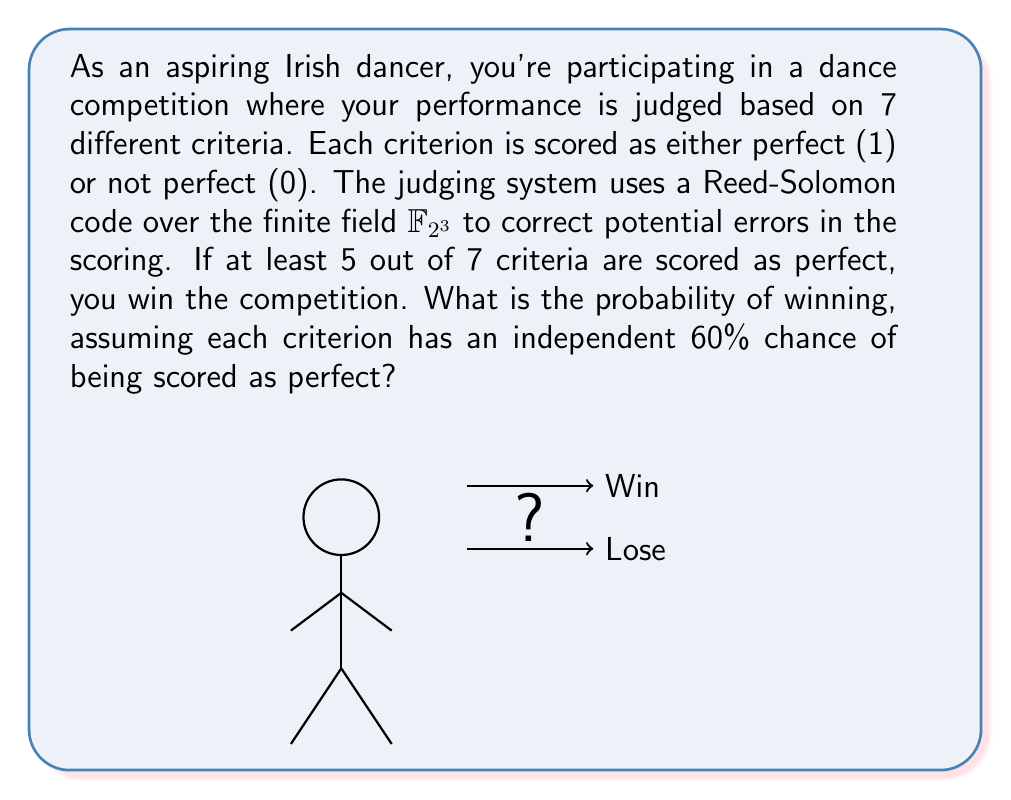Can you answer this question? Let's approach this step-by-step:

1) First, we need to understand that we're dealing with a binomial probability distribution. We have 7 independent trials (criteria), each with a 60% chance of success.

2) We win if we get 5, 6, or 7 perfect scores. So we need to calculate:
   $P(\text{win}) = P(X=5) + P(X=6) + P(X=7)$
   where $X$ is the number of perfect scores.

3) The probability of each outcome is given by the binomial probability formula:
   $P(X=k) = \binom{n}{k} p^k (1-p)^{n-k}$
   where $n=7$, $p=0.6$, and $k$ is the number of successes.

4) Let's calculate each probability:

   For $k=5$: 
   $P(X=5) = \binom{7}{5} (0.6)^5 (0.4)^2 = 21 \cdot 0.07776 \cdot 0.16 = 0.2592$

   For $k=6$:
   $P(X=6) = \binom{7}{6} (0.6)^6 (0.4)^1 = 7 \cdot 0.046656 \cdot 0.4 = 0.1306$

   For $k=7$:
   $P(X=7) = \binom{7}{7} (0.6)^7 (0.4)^0 = 1 \cdot 0.0279936 \cdot 1 = 0.0280$

5) Now, we sum these probabilities:
   $P(\text{win}) = 0.2592 + 0.1306 + 0.0280 = 0.4178$

6) The use of Reed-Solomon codes over $\mathbb{F}_{2^3}$ in the judging system ensures that even if there are some errors in the individual criterion scores, the overall result (win or lose) will likely be correct as long as the majority of scores are accurate.
Answer: $0.4178$ or approximately $41.78\%$ 